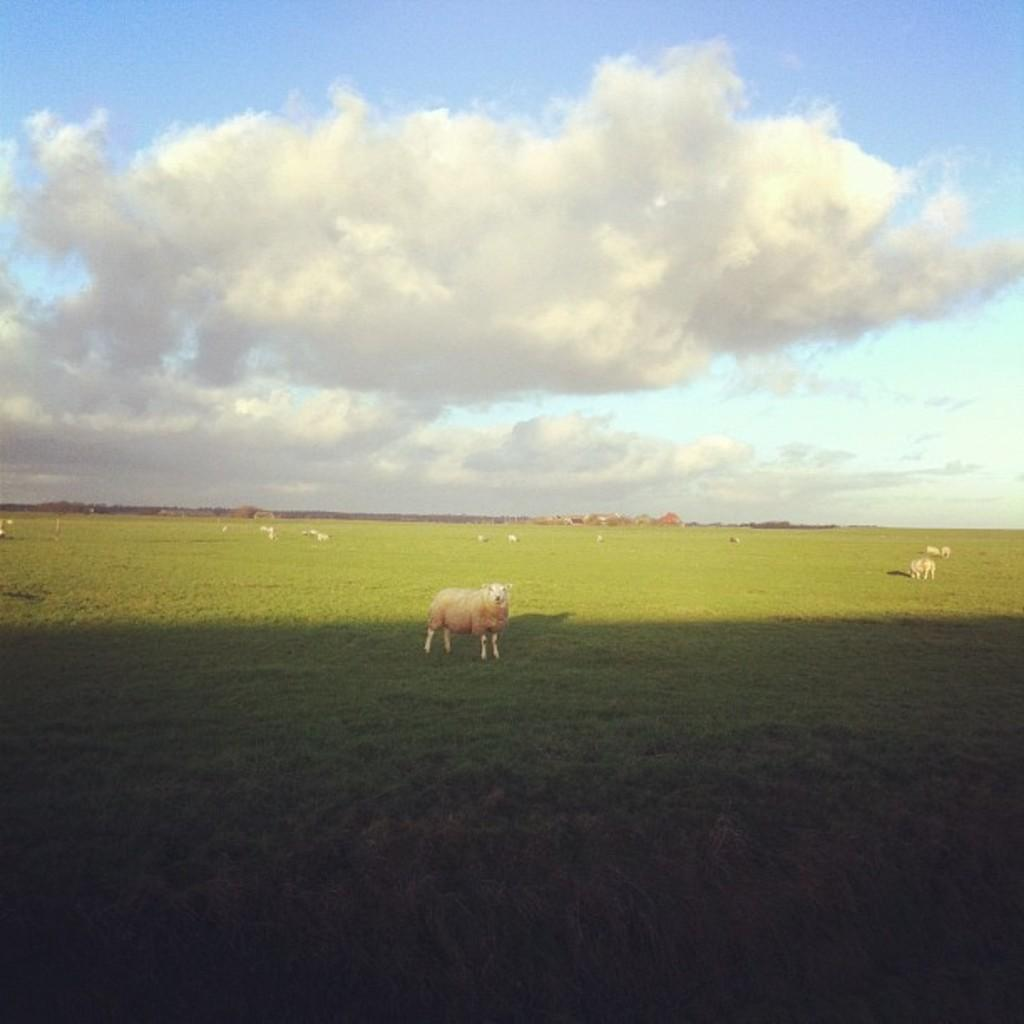What type of animals can be seen on the ground in the image? There are animals on the ground in the image, but their specific type is not mentioned in the facts. What type of vegetation is visible on the ground in the image? There is grass visible in the image. What can be seen in the background of the image? There is sky visible in the background of the image. What is present in the sky in the image? Clouds are present in the sky. What type of riddle is being solved by the animals in the image? There is no riddle being solved by the animals in the image; they are simply present on the ground. How many clocks are visible in the image? There are no clocks visible in the image. 